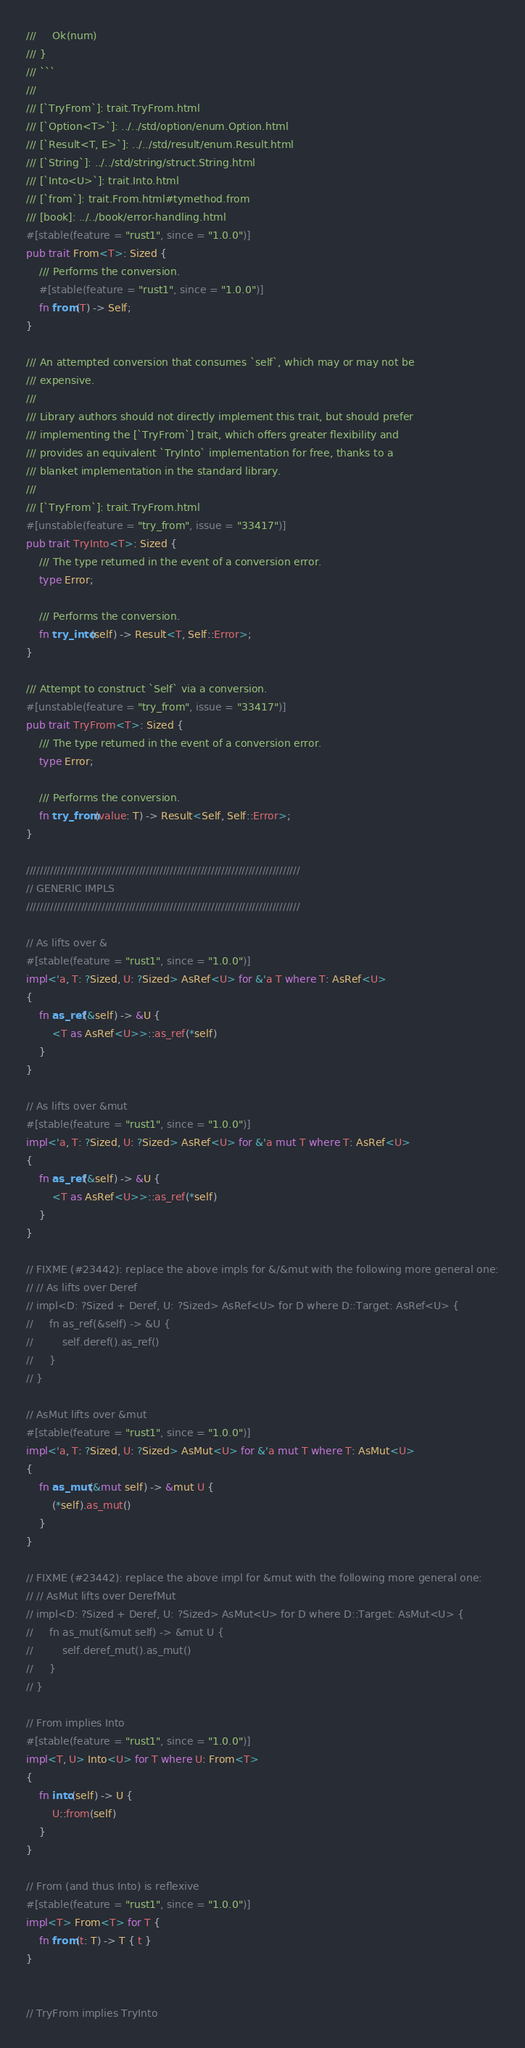<code> <loc_0><loc_0><loc_500><loc_500><_Rust_>///     Ok(num)
/// }
/// ```
///
/// [`TryFrom`]: trait.TryFrom.html
/// [`Option<T>`]: ../../std/option/enum.Option.html
/// [`Result<T, E>`]: ../../std/result/enum.Result.html
/// [`String`]: ../../std/string/struct.String.html
/// [`Into<U>`]: trait.Into.html
/// [`from`]: trait.From.html#tymethod.from
/// [book]: ../../book/error-handling.html
#[stable(feature = "rust1", since = "1.0.0")]
pub trait From<T>: Sized {
    /// Performs the conversion.
    #[stable(feature = "rust1", since = "1.0.0")]
    fn from(T) -> Self;
}

/// An attempted conversion that consumes `self`, which may or may not be
/// expensive.
///
/// Library authors should not directly implement this trait, but should prefer
/// implementing the [`TryFrom`] trait, which offers greater flexibility and
/// provides an equivalent `TryInto` implementation for free, thanks to a
/// blanket implementation in the standard library.
///
/// [`TryFrom`]: trait.TryFrom.html
#[unstable(feature = "try_from", issue = "33417")]
pub trait TryInto<T>: Sized {
    /// The type returned in the event of a conversion error.
    type Error;

    /// Performs the conversion.
    fn try_into(self) -> Result<T, Self::Error>;
}

/// Attempt to construct `Self` via a conversion.
#[unstable(feature = "try_from", issue = "33417")]
pub trait TryFrom<T>: Sized {
    /// The type returned in the event of a conversion error.
    type Error;

    /// Performs the conversion.
    fn try_from(value: T) -> Result<Self, Self::Error>;
}

////////////////////////////////////////////////////////////////////////////////
// GENERIC IMPLS
////////////////////////////////////////////////////////////////////////////////

// As lifts over &
#[stable(feature = "rust1", since = "1.0.0")]
impl<'a, T: ?Sized, U: ?Sized> AsRef<U> for &'a T where T: AsRef<U>
{
    fn as_ref(&self) -> &U {
        <T as AsRef<U>>::as_ref(*self)
    }
}

// As lifts over &mut
#[stable(feature = "rust1", since = "1.0.0")]
impl<'a, T: ?Sized, U: ?Sized> AsRef<U> for &'a mut T where T: AsRef<U>
{
    fn as_ref(&self) -> &U {
        <T as AsRef<U>>::as_ref(*self)
    }
}

// FIXME (#23442): replace the above impls for &/&mut with the following more general one:
// // As lifts over Deref
// impl<D: ?Sized + Deref, U: ?Sized> AsRef<U> for D where D::Target: AsRef<U> {
//     fn as_ref(&self) -> &U {
//         self.deref().as_ref()
//     }
// }

// AsMut lifts over &mut
#[stable(feature = "rust1", since = "1.0.0")]
impl<'a, T: ?Sized, U: ?Sized> AsMut<U> for &'a mut T where T: AsMut<U>
{
    fn as_mut(&mut self) -> &mut U {
        (*self).as_mut()
    }
}

// FIXME (#23442): replace the above impl for &mut with the following more general one:
// // AsMut lifts over DerefMut
// impl<D: ?Sized + Deref, U: ?Sized> AsMut<U> for D where D::Target: AsMut<U> {
//     fn as_mut(&mut self) -> &mut U {
//         self.deref_mut().as_mut()
//     }
// }

// From implies Into
#[stable(feature = "rust1", since = "1.0.0")]
impl<T, U> Into<U> for T where U: From<T>
{
    fn into(self) -> U {
        U::from(self)
    }
}

// From (and thus Into) is reflexive
#[stable(feature = "rust1", since = "1.0.0")]
impl<T> From<T> for T {
    fn from(t: T) -> T { t }
}


// TryFrom implies TryInto</code> 